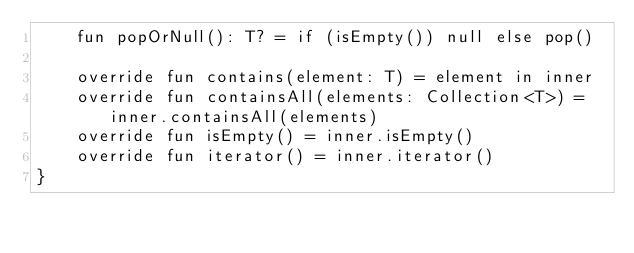<code> <loc_0><loc_0><loc_500><loc_500><_Kotlin_>    fun popOrNull(): T? = if (isEmpty()) null else pop()

    override fun contains(element: T) = element in inner
    override fun containsAll(elements: Collection<T>) = inner.containsAll(elements)
    override fun isEmpty() = inner.isEmpty()
    override fun iterator() = inner.iterator()
}</code> 